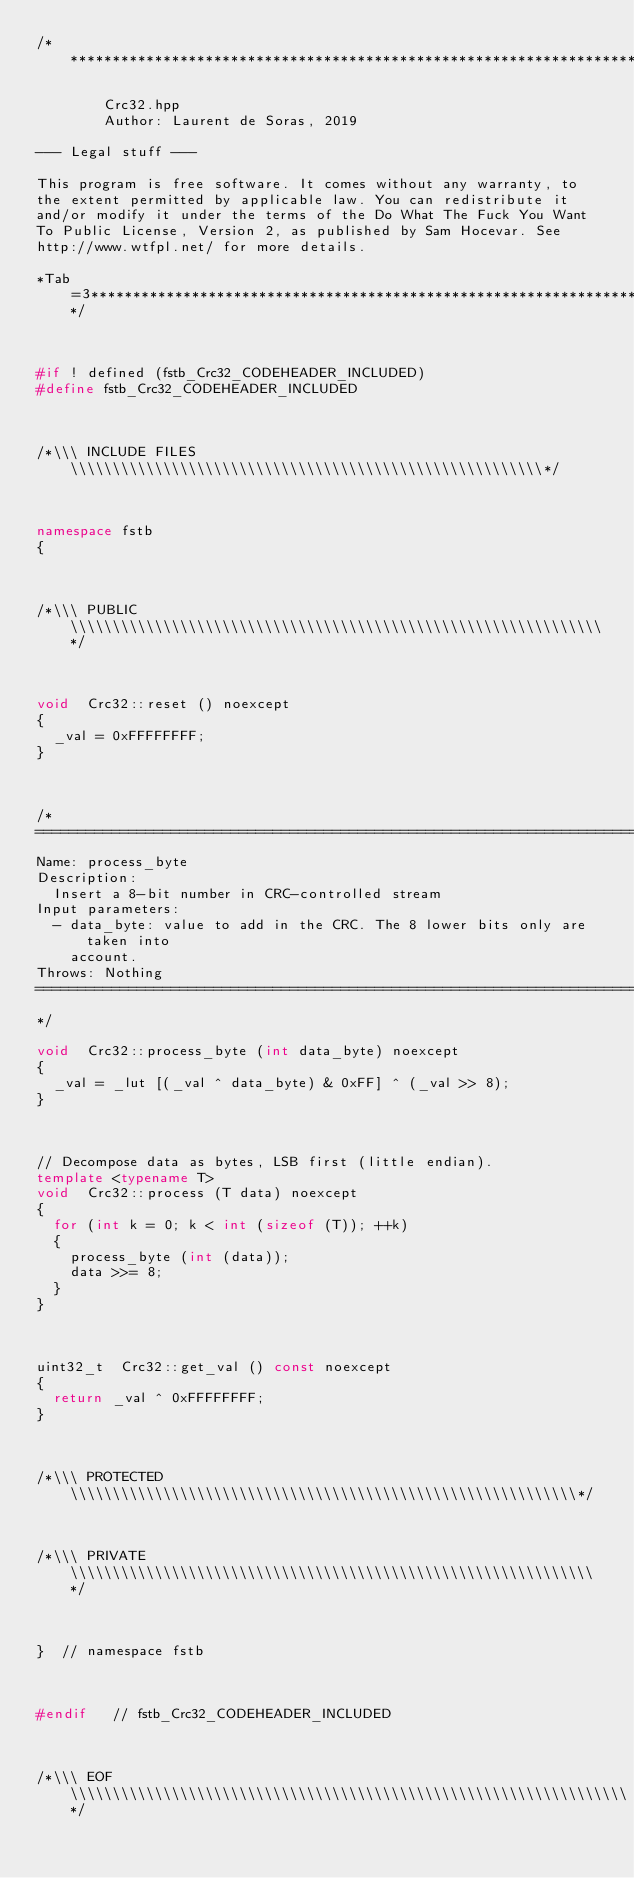<code> <loc_0><loc_0><loc_500><loc_500><_C++_>/*****************************************************************************

        Crc32.hpp
        Author: Laurent de Soras, 2019

--- Legal stuff ---

This program is free software. It comes without any warranty, to
the extent permitted by applicable law. You can redistribute it
and/or modify it under the terms of the Do What The Fuck You Want
To Public License, Version 2, as published by Sam Hocevar. See
http://www.wtfpl.net/ for more details.

*Tab=3***********************************************************************/



#if ! defined (fstb_Crc32_CODEHEADER_INCLUDED)
#define fstb_Crc32_CODEHEADER_INCLUDED



/*\\\ INCLUDE FILES \\\\\\\\\\\\\\\\\\\\\\\\\\\\\\\\\\\\\\\\\\\\\\\\\\\\\\\\*/



namespace fstb
{



/*\\\ PUBLIC \\\\\\\\\\\\\\\\\\\\\\\\\\\\\\\\\\\\\\\\\\\\\\\\\\\\\\\\\\\\\\\*/



void	Crc32::reset () noexcept
{
	_val = 0xFFFFFFFF;
}



/*
==============================================================================
Name: process_byte
Description:
	Insert a 8-bit number in CRC-controlled stream
Input parameters:
	- data_byte: value to add in the CRC. The 8 lower bits only are taken into
		account.
Throws: Nothing
==============================================================================
*/

void	Crc32::process_byte (int data_byte) noexcept
{
	_val = _lut [(_val ^ data_byte) & 0xFF] ^ (_val >> 8);
}



// Decompose data as bytes, LSB first (little endian).
template <typename T>
void	Crc32::process (T data) noexcept
{
	for (int k = 0; k < int (sizeof (T)); ++k)
	{
		process_byte (int (data));
		data >>= 8;
	}
}



uint32_t	Crc32::get_val () const noexcept
{
	return _val ^ 0xFFFFFFFF;
}



/*\\\ PROTECTED \\\\\\\\\\\\\\\\\\\\\\\\\\\\\\\\\\\\\\\\\\\\\\\\\\\\\\\\\\\\*/



/*\\\ PRIVATE \\\\\\\\\\\\\\\\\\\\\\\\\\\\\\\\\\\\\\\\\\\\\\\\\\\\\\\\\\\\\\*/



}  // namespace fstb



#endif   // fstb_Crc32_CODEHEADER_INCLUDED



/*\\\ EOF \\\\\\\\\\\\\\\\\\\\\\\\\\\\\\\\\\\\\\\\\\\\\\\\\\\\\\\\\\\\\\\\\\*/
</code> 